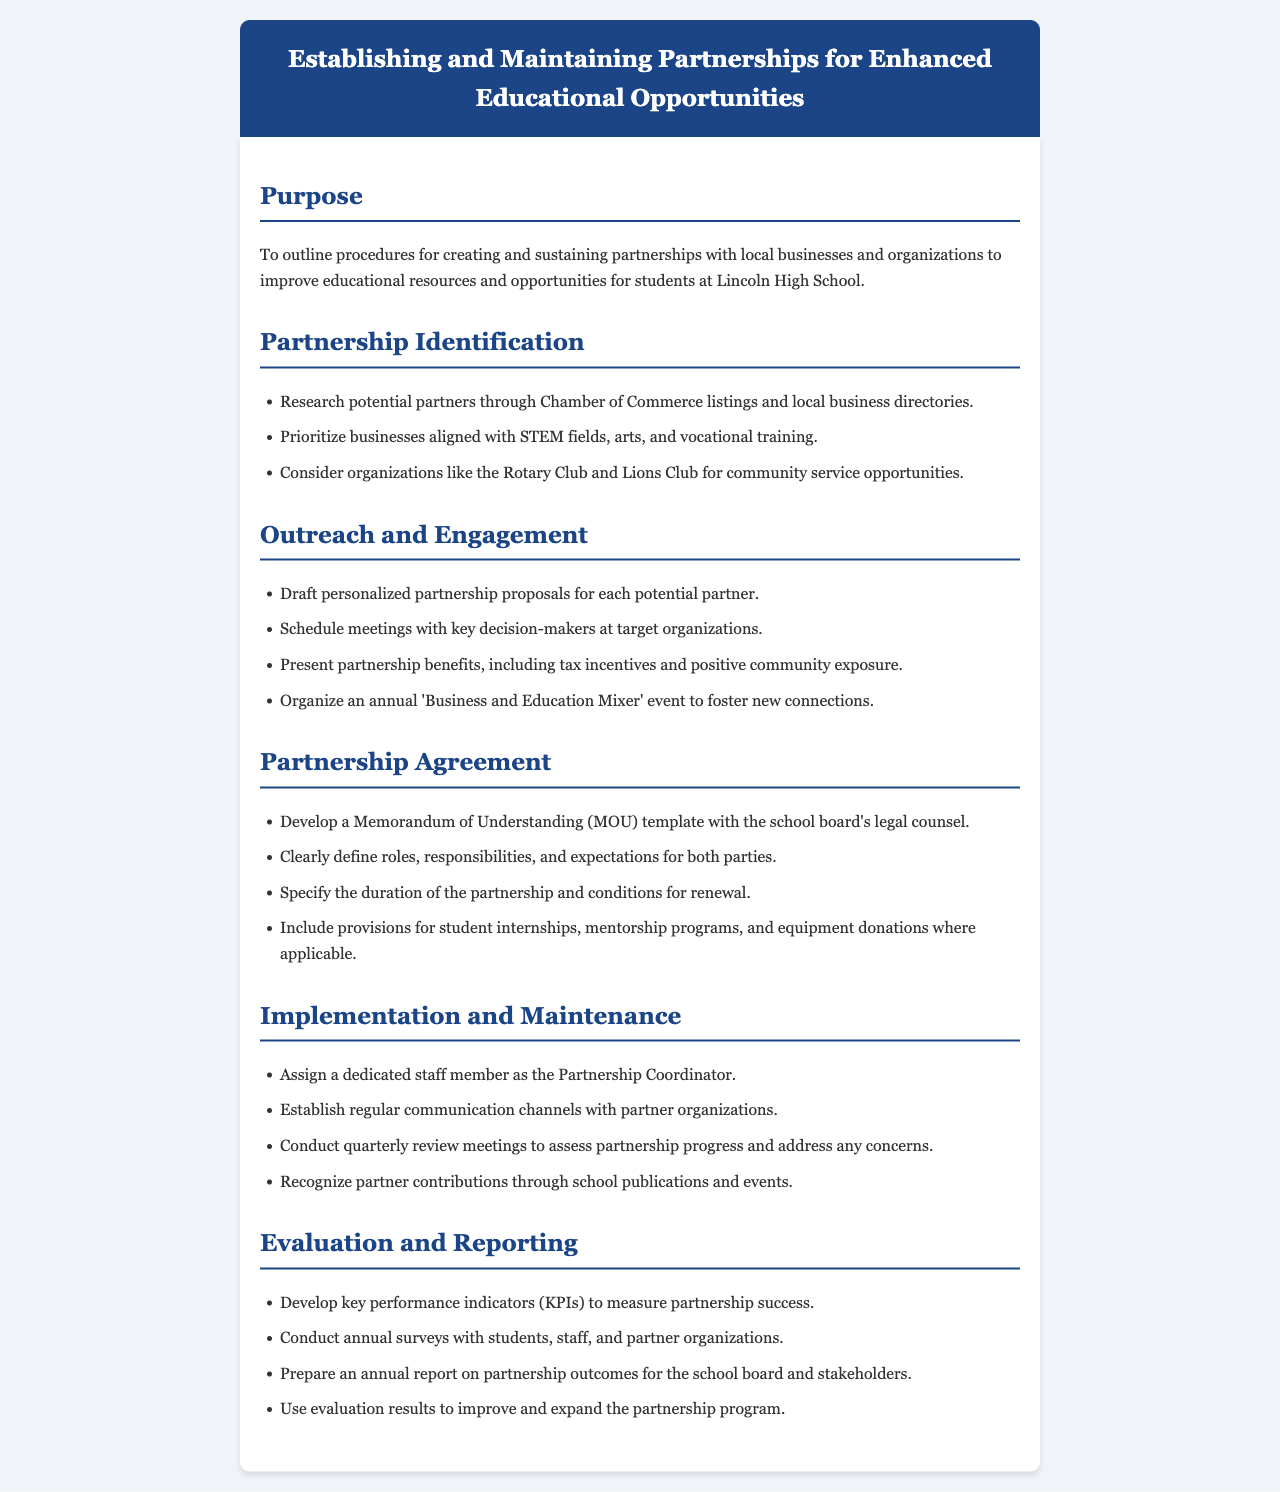what is the purpose of the document? The purpose is to outline procedures for creating and sustaining partnerships with local businesses and organizations to improve educational resources and opportunities for students at Lincoln High School.
Answer: To outline procedures for creating and sustaining partnerships with local businesses and organizations to improve educational resources and opportunities for students at Lincoln High School which organizations are considered for outreach? The organizations mentioned that can be considered for community service opportunities include the Rotary Club and Lions Club.
Answer: Rotary Club and Lions Club what is included in the Partnership Agreement section? The Partnership Agreement section specifies responsibilities, duration, and student-related provisions among other details.
Answer: Roles, responsibilities, and expectations for both parties who is responsible for partnership coordination? The document states that a dedicated staff member will be assigned as the Partnership Coordinator.
Answer: A dedicated staff member how often should review meetings be conducted? The document recommends conducting quarterly review meetings to assess partnership progress.
Answer: Quarterly what type of event is organized annually for partnerships? An event called "Business and Education Mixer" is organized annually to foster new connections.
Answer: Business and Education Mixer what do KPIs measure in the evaluation section? Key performance indicators (KPIs) measure partnership success.
Answer: Partnership success what is developed to measure partnership outcomes? An annual report is prepared on partnership outcomes for the school board and stakeholders.
Answer: Annual report 